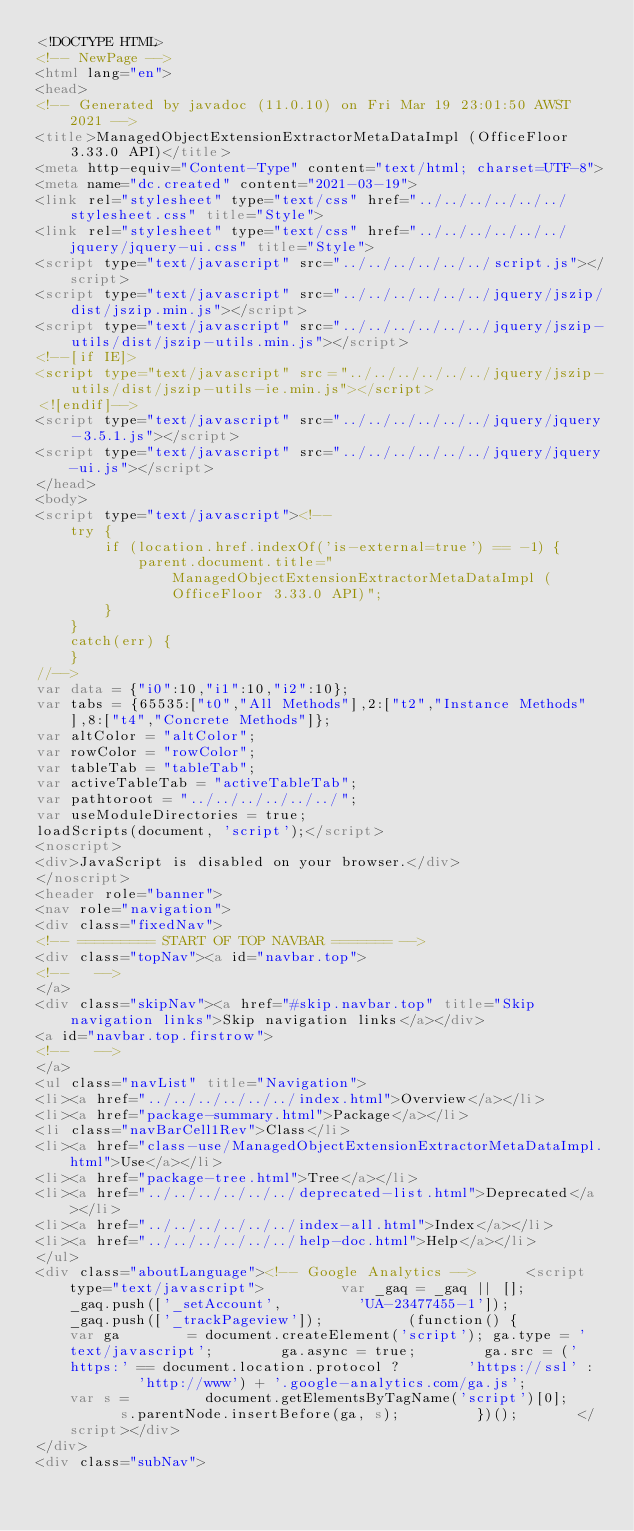<code> <loc_0><loc_0><loc_500><loc_500><_HTML_><!DOCTYPE HTML>
<!-- NewPage -->
<html lang="en">
<head>
<!-- Generated by javadoc (11.0.10) on Fri Mar 19 23:01:50 AWST 2021 -->
<title>ManagedObjectExtensionExtractorMetaDataImpl (OfficeFloor 3.33.0 API)</title>
<meta http-equiv="Content-Type" content="text/html; charset=UTF-8">
<meta name="dc.created" content="2021-03-19">
<link rel="stylesheet" type="text/css" href="../../../../../../stylesheet.css" title="Style">
<link rel="stylesheet" type="text/css" href="../../../../../../jquery/jquery-ui.css" title="Style">
<script type="text/javascript" src="../../../../../../script.js"></script>
<script type="text/javascript" src="../../../../../../jquery/jszip/dist/jszip.min.js"></script>
<script type="text/javascript" src="../../../../../../jquery/jszip-utils/dist/jszip-utils.min.js"></script>
<!--[if IE]>
<script type="text/javascript" src="../../../../../../jquery/jszip-utils/dist/jszip-utils-ie.min.js"></script>
<![endif]-->
<script type="text/javascript" src="../../../../../../jquery/jquery-3.5.1.js"></script>
<script type="text/javascript" src="../../../../../../jquery/jquery-ui.js"></script>
</head>
<body>
<script type="text/javascript"><!--
    try {
        if (location.href.indexOf('is-external=true') == -1) {
            parent.document.title="ManagedObjectExtensionExtractorMetaDataImpl (OfficeFloor 3.33.0 API)";
        }
    }
    catch(err) {
    }
//-->
var data = {"i0":10,"i1":10,"i2":10};
var tabs = {65535:["t0","All Methods"],2:["t2","Instance Methods"],8:["t4","Concrete Methods"]};
var altColor = "altColor";
var rowColor = "rowColor";
var tableTab = "tableTab";
var activeTableTab = "activeTableTab";
var pathtoroot = "../../../../../../";
var useModuleDirectories = true;
loadScripts(document, 'script');</script>
<noscript>
<div>JavaScript is disabled on your browser.</div>
</noscript>
<header role="banner">
<nav role="navigation">
<div class="fixedNav">
<!-- ========= START OF TOP NAVBAR ======= -->
<div class="topNav"><a id="navbar.top">
<!--   -->
</a>
<div class="skipNav"><a href="#skip.navbar.top" title="Skip navigation links">Skip navigation links</a></div>
<a id="navbar.top.firstrow">
<!--   -->
</a>
<ul class="navList" title="Navigation">
<li><a href="../../../../../../index.html">Overview</a></li>
<li><a href="package-summary.html">Package</a></li>
<li class="navBarCell1Rev">Class</li>
<li><a href="class-use/ManagedObjectExtensionExtractorMetaDataImpl.html">Use</a></li>
<li><a href="package-tree.html">Tree</a></li>
<li><a href="../../../../../../deprecated-list.html">Deprecated</a></li>
<li><a href="../../../../../../index-all.html">Index</a></li>
<li><a href="../../../../../../help-doc.html">Help</a></li>
</ul>
<div class="aboutLanguage"><!-- Google Analytics --> 			<script type="text/javascript"> 				var _gaq = _gaq || []; 				_gaq.push(['_setAccount', 				'UA-23477455-1']); 				_gaq.push(['_trackPageview']);  				(function() { 				var ga 				= document.createElement('script'); ga.type = 'text/javascript'; 				ga.async = true; 				ga.src = ('https:' == document.location.protocol ? 				'https://ssl' : 				'http://www') + '.google-analytics.com/ga.js'; 				var s = 				document.getElementsByTagName('script')[0]; 				s.parentNode.insertBefore(ga, s); 				})(); 			</script></div>
</div>
<div class="subNav"></code> 